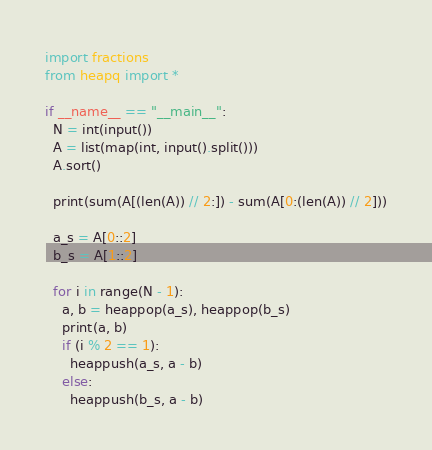Convert code to text. <code><loc_0><loc_0><loc_500><loc_500><_Python_>import fractions
from heapq import *

if __name__ == "__main__":
  N = int(input())
  A = list(map(int, input().split()))
  A.sort()
  
  print(sum(A[(len(A)) // 2:]) - sum(A[0:(len(A)) // 2]))

  a_s = A[0::2]
  b_s = A[1::2]

  for i in range(N - 1):
    a, b = heappop(a_s), heappop(b_s)
    print(a, b)
    if (i % 2 == 1):
      heappush(a_s, a - b)
    else:
      heappush(b_s, a - b)
</code> 